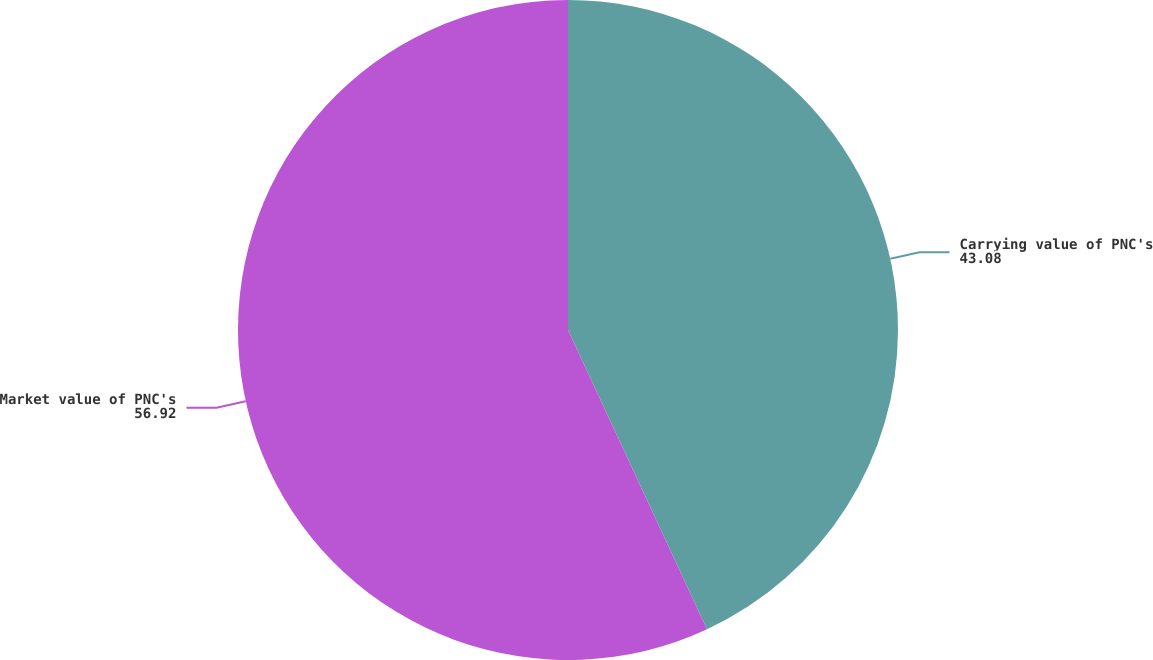Convert chart. <chart><loc_0><loc_0><loc_500><loc_500><pie_chart><fcel>Carrying value of PNC's<fcel>Market value of PNC's<nl><fcel>43.08%<fcel>56.92%<nl></chart> 